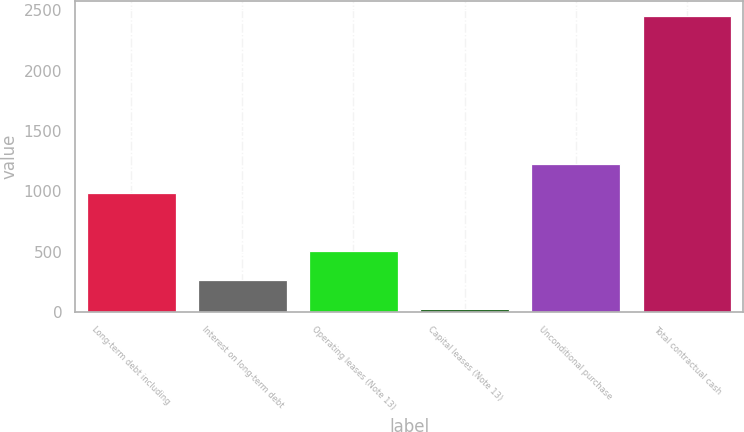Convert chart to OTSL. <chart><loc_0><loc_0><loc_500><loc_500><bar_chart><fcel>Long-term debt including<fcel>Interest on long-term debt<fcel>Operating leases (Note 13)<fcel>Capital leases (Note 13)<fcel>Unconditional purchase<fcel>Total contractual cash<nl><fcel>986<fcel>264.9<fcel>507.8<fcel>22<fcel>1228.9<fcel>2451<nl></chart> 